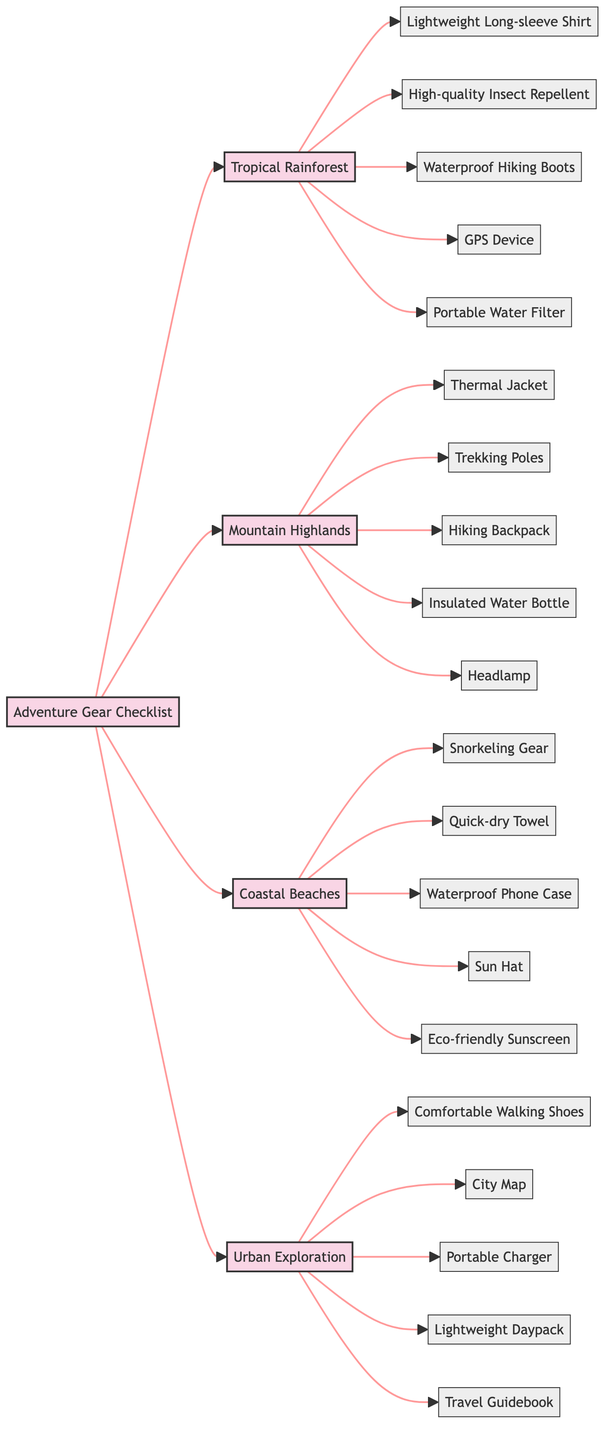What are the essential gears for the Tropical Rainforest region? The Tropical Rainforest region is represented by node B. By tracing its connections, we can see that the essential gears listed are: Lightweight Long-sleeve Shirt, High-quality Insect Repellent, Waterproof Hiking Boots, GPS Device, and Portable Water Filter.
Answer: Lightweight Long-sleeve Shirt, High-quality Insect Repellent, Waterproof Hiking Boots, GPS Device, Portable Water Filter How many gear items are listed for the Coastal Beaches? The Coastal Beaches region is represented by node D. By checking its connections, we count the following gear items: Snorkeling Gear, Quick-dry Towel, Waterproof Phone Case, Sun Hat, and Eco-friendly Sunscreen—totalling five items.
Answer: 5 Which region requires a Thermal Jacket? The Thermal Jacket is specifically connected to the Mountain Highlands region, which is indicated by node C. Therefore, it is required in Mountain Highlands (Boquete).
Answer: Mountain Highlands What is the only gear that is common between Coastal Beaches and Urban Exploration? Reviewing the gear listed for Coastal Beaches (D) and Urban Exploration (E), we see that they do not share any gear items. Therefore, there is no common gear between these regions.
Answer: None Which regions require a GPS device? The GPS Device is specifically listed under the Tropical Rainforest region (B). By examining the flowchart, we find it is the only region that requires a GPS Device.
Answer: Tropical Rainforest How many total regions are shown in the diagram? The diagram includes a total of four regions: Tropical Rainforest, Mountain Highlands, Coastal Beaches, and Urban Exploration. By counting the nodes directly connected to the main Adventure Gear Checklist node, we confirm there are four.
Answer: 4 Which piece of gear is essential for both Mountain Highlands and Urban Exploration? After checking the gear listed for both Mountain Highlands (C) and Urban Exploration (E), we find that both regions do not share any gear items, as each list is unique to that particular region.
Answer: None What gear is associated with Urban Exploration? The gear listed under the Urban Exploration region (E) includes: Comfortable Walking Shoes, City Map, Portable Charger, Lightweight Daypack, and Travel Guidebook. By following the flow to node E, we can directly identify these items.
Answer: Comfortable Walking Shoes, City Map, Portable Charger, Lightweight Daypack, Travel Guidebook 